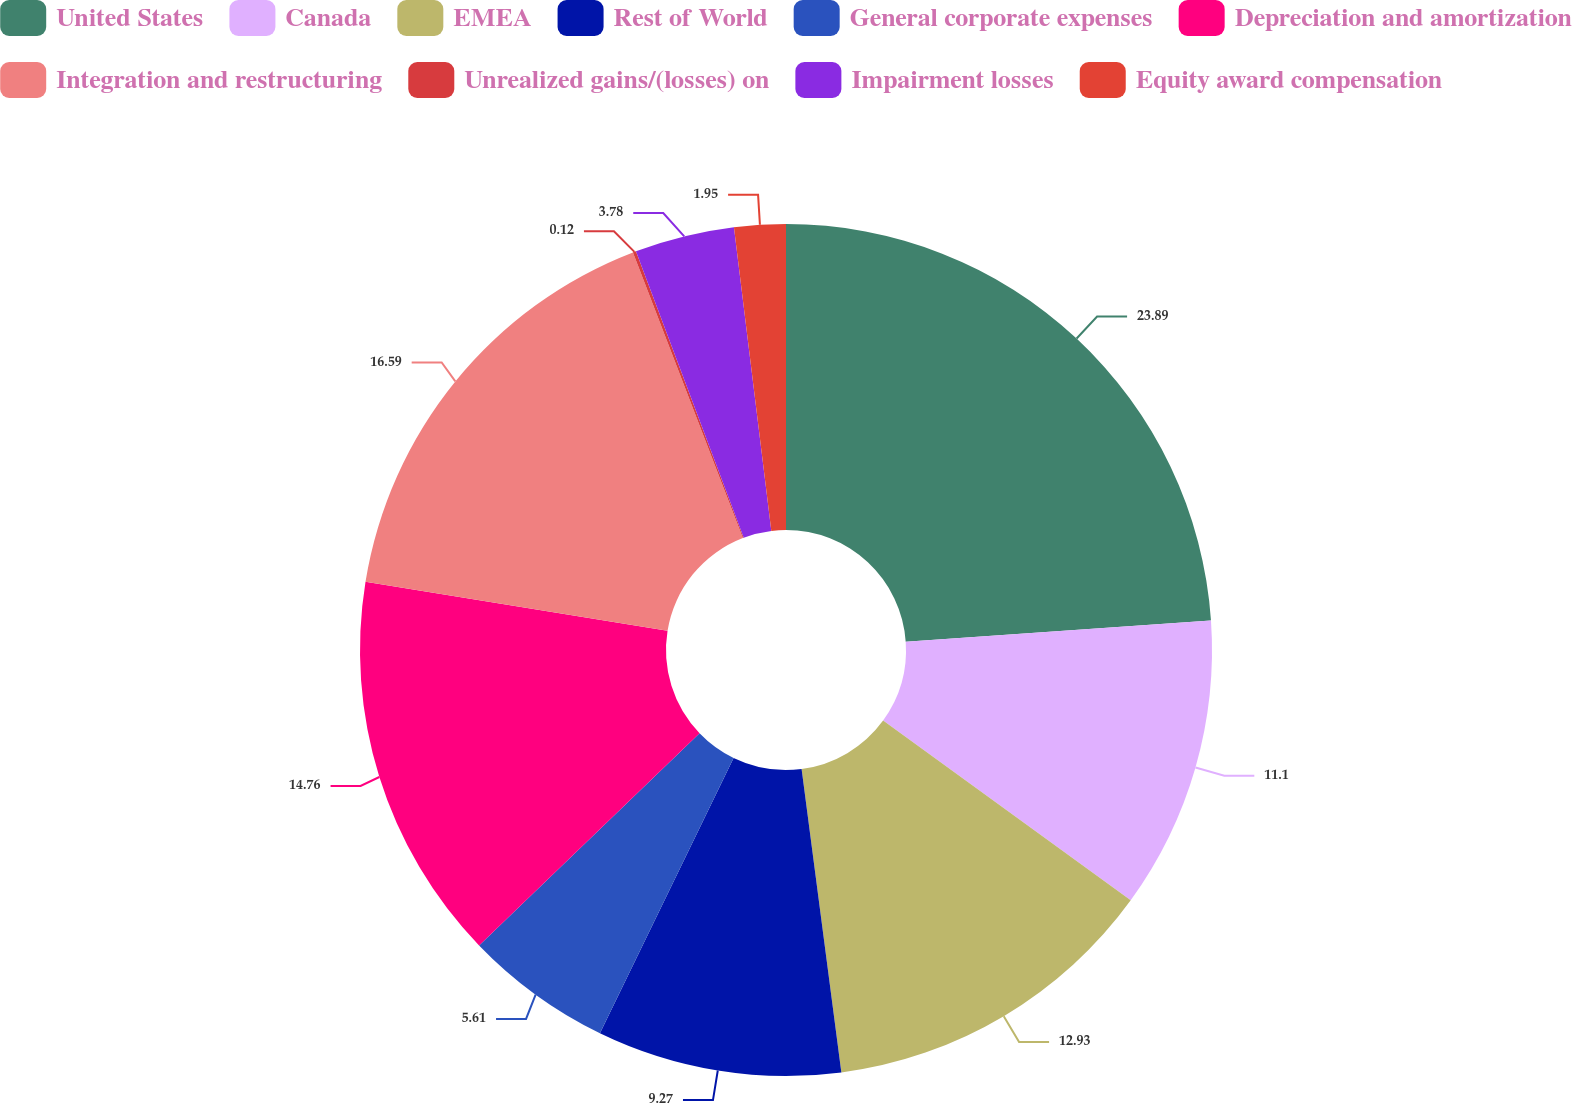Convert chart. <chart><loc_0><loc_0><loc_500><loc_500><pie_chart><fcel>United States<fcel>Canada<fcel>EMEA<fcel>Rest of World<fcel>General corporate expenses<fcel>Depreciation and amortization<fcel>Integration and restructuring<fcel>Unrealized gains/(losses) on<fcel>Impairment losses<fcel>Equity award compensation<nl><fcel>23.9%<fcel>11.1%<fcel>12.93%<fcel>9.27%<fcel>5.61%<fcel>14.76%<fcel>16.59%<fcel>0.12%<fcel>3.78%<fcel>1.95%<nl></chart> 